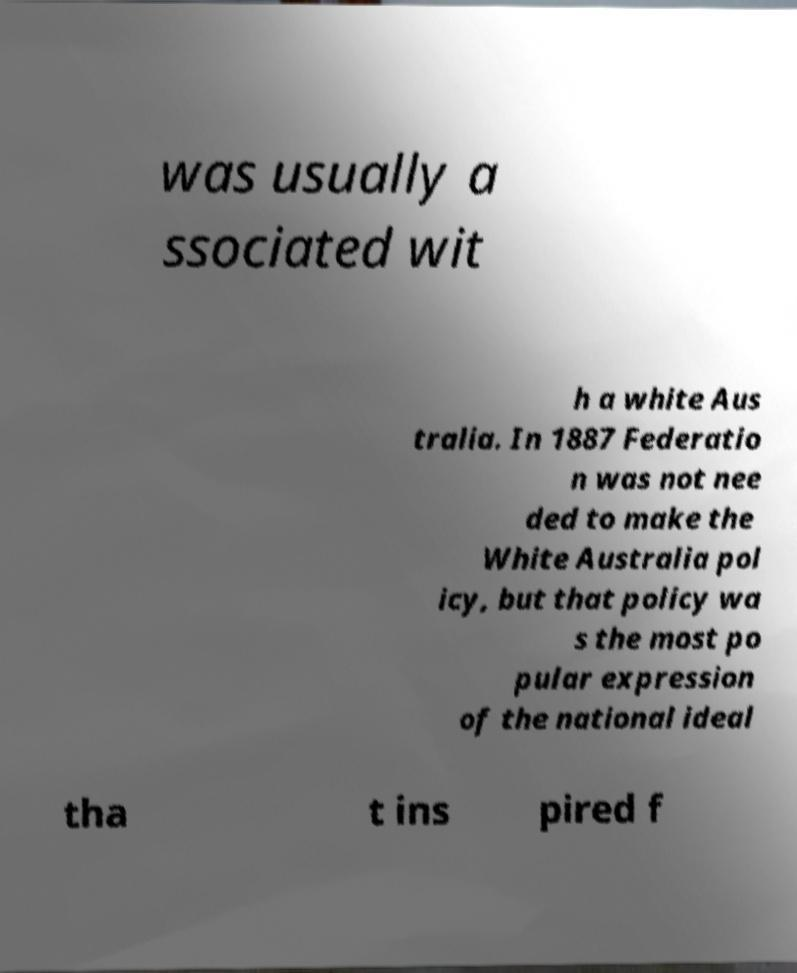Can you accurately transcribe the text from the provided image for me? was usually a ssociated wit h a white Aus tralia. In 1887 Federatio n was not nee ded to make the White Australia pol icy, but that policy wa s the most po pular expression of the national ideal tha t ins pired f 